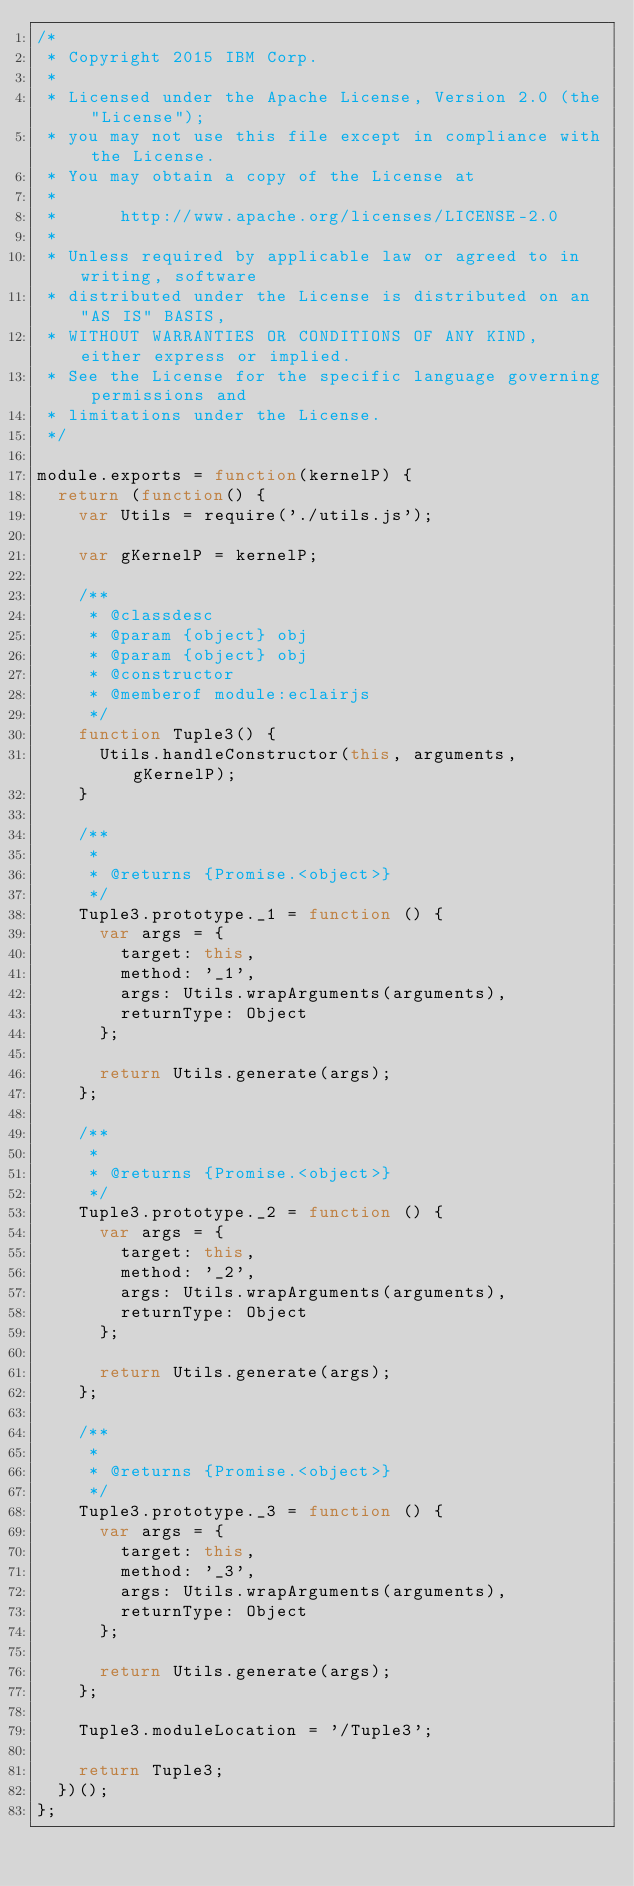Convert code to text. <code><loc_0><loc_0><loc_500><loc_500><_JavaScript_>/*
 * Copyright 2015 IBM Corp.
 *
 * Licensed under the Apache License, Version 2.0 (the "License");
 * you may not use this file except in compliance with the License.
 * You may obtain a copy of the License at
 *
 *      http://www.apache.org/licenses/LICENSE-2.0
 *
 * Unless required by applicable law or agreed to in writing, software
 * distributed under the License is distributed on an "AS IS" BASIS,
 * WITHOUT WARRANTIES OR CONDITIONS OF ANY KIND, either express or implied.
 * See the License for the specific language governing permissions and
 * limitations under the License.
 */

module.exports = function(kernelP) {
  return (function() {
    var Utils = require('./utils.js');

    var gKernelP = kernelP;

    /**
     * @classdesc
     * @param {object} obj
     * @param {object} obj
     * @constructor
     * @memberof module:eclairjs
     */
    function Tuple3() {
      Utils.handleConstructor(this, arguments, gKernelP);
    }

    /**
     *
     * @returns {Promise.<object>}
     */
    Tuple3.prototype._1 = function () {
      var args = {
        target: this,
        method: '_1',
        args: Utils.wrapArguments(arguments),
        returnType: Object
      };

      return Utils.generate(args);
    };

    /**
     *
     * @returns {Promise.<object>}
     */
    Tuple3.prototype._2 = function () {
      var args = {
        target: this,
        method: '_2',
        args: Utils.wrapArguments(arguments),
        returnType: Object
      };

      return Utils.generate(args);
    };

    /**
     *
     * @returns {Promise.<object>}
     */
    Tuple3.prototype._3 = function () {
      var args = {
        target: this,
        method: '_3',
        args: Utils.wrapArguments(arguments),
        returnType: Object
      };

      return Utils.generate(args);
    };

    Tuple3.moduleLocation = '/Tuple3';

    return Tuple3;
  })();
};</code> 